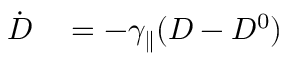Convert formula to latex. <formula><loc_0><loc_0><loc_500><loc_500>\begin{array} { r l } { \dot { D } } & = - \gamma _ { \| } ( D - D ^ { 0 } ) } \end{array}</formula> 